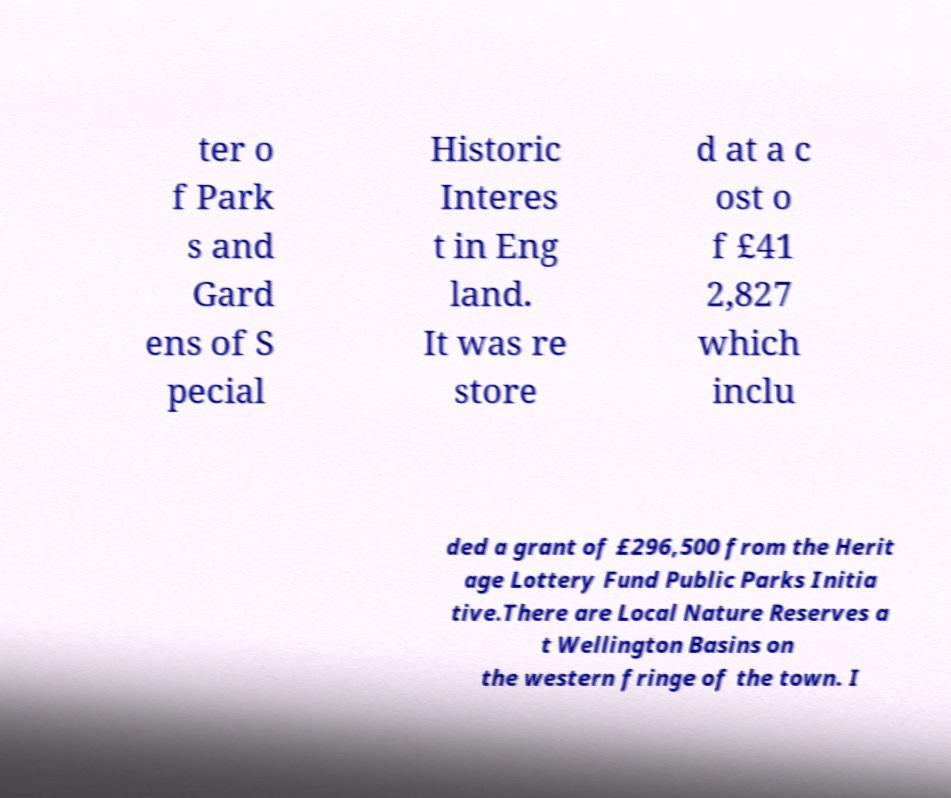Can you accurately transcribe the text from the provided image for me? ter o f Park s and Gard ens of S pecial Historic Interes t in Eng land. It was re store d at a c ost o f £41 2,827 which inclu ded a grant of £296,500 from the Herit age Lottery Fund Public Parks Initia tive.There are Local Nature Reserves a t Wellington Basins on the western fringe of the town. I 